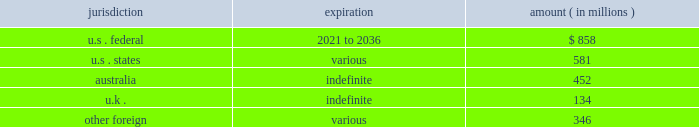News corporation notes to the consolidated financial statements as of june 30 , 2016 , the company had income tax net operating loss carryforwards ( nols ) ( gross , net of uncertain tax benefits ) , in various jurisdictions as follows : jurisdiction expiration amount ( in millions ) .
Utilization of the nols is dependent on generating sufficient taxable income from our operations in each of the respective jurisdictions to which the nols relate , while taking into account limitations and/or restrictions on our ability to use them .
Certain of our u.s .
Federal nols were acquired as part of the acquisitions of move and harlequin and are subject to limitations as promulgated under section 382 of the code .
Section 382 of the code limits the amount of acquired nols that we can use on an annual basis to offset future u.s .
Consolidated taxable income .
The nols are also subject to review by relevant tax authorities in the jurisdictions to which they relate .
The company recorded a deferred tax asset of $ 580 million and $ 540 million ( net of approximately $ 53 million and $ 95 million , respectively , of unrecognized tax benefits ) associated with its nols as of june 30 , 2016 and 2015 , respectively .
Significant judgment is applied in assessing our ability to realize our nols and other tax assets .
Management assesses the available positive and negative evidence to estimate if sufficient future taxable income will be generated to utilize existing deferred tax assets within the applicable expiration period .
On the basis of this evaluation , valuation allowances of $ 97 million and $ 304 million have been established to reduce the deferred tax asset associated with the company 2019s nols to an amount that will more likely than not be realized as of june 30 , 2016 and 2015 , respectively .
The amount of the nol deferred tax asset considered realizable , however , could be adjusted if estimates of future taxable income during the carryforward period are reduced or if objective negative evidence in the form of cumulative losses occurs .
As of june 30 , 2016 , the company had approximately $ 1.6 billion and $ 1.7 billion of capital loss carryforwards in australia and the u.k. , respectively , which may be carried forward indefinitely and which are subject to tax authority review .
Realization of our capital losses is dependent on generating capital gain taxable income and satisfying certain continuity of business requirements .
The company recorded a deferred tax asset of $ 803 million and $ 892 million as of june 30 , 2016 and 2015 , respectively for these capital loss carryforwards , however , it is more likely than not that the company will not generate capital gain income in the normal course of business in these jurisdictions .
Accordingly , valuation allowances of $ 803 million and $ 892 million have been established to reduce the capital loss carryforward deferred tax asset to an amount that will more likely than not be realized as of june 30 , 2016 and 2015 , respectively .
As of june 30 , 2016 , the company had approximately $ 26 million of u.s .
Federal tax credit carryforward which includes $ 22 million of foreign tax credits and $ 4 million of research & development credits which begin to expire in 2025 and 2036 , respectively .
As of june 30 , 2016 , the company had approximately $ 5 million of non-u.s .
Tax credit carryforwards which expire in various amounts beginning in 2025 and $ 8 million of state tax credit carryforwards ( net of u.s .
Federal benefit ) , of which the balance can be carried forward indefinitely .
In accordance with the company 2019s accounting policy , a valuation allowance of $ 5 million has been established to reduce the deferred tax asset associated with the company 2019s non-u.s .
And state credit carryforwards to an amount that will more likely than not be realized as of june 30 , 2016. .
As of june 302016 what was the ratio of the u.s . federal net operating loss carry forwards compared to the states? 
Rationale: as of june 302016 there was $ 1.48 u.s . federal net operating loss carry forwards compared to the $ 1 states
Computations: (858 / 581)
Answer: 1.47676. 